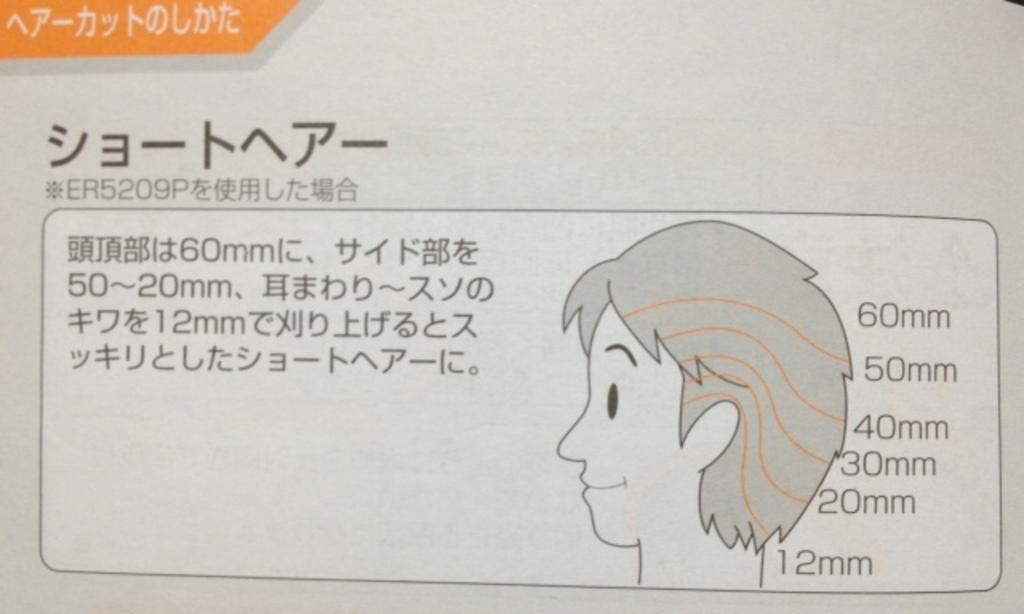What is present on the paper in the image? There is text and a person's picture on the paper. Can you describe the content of the text on the paper? Unfortunately, the specific content of the text cannot be determined from the image. What is the purpose of the person's picture on the paper? The purpose of the person's picture on the paper is not clear from the image alone. How does the maid react to the shocking news on the paper? There is no maid or shocking news present in the image. The image only shows a paper with text and a person's picture. 